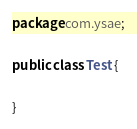Convert code to text. <code><loc_0><loc_0><loc_500><loc_500><_Java_>package com.ysae;

public class Test {

}
</code> 